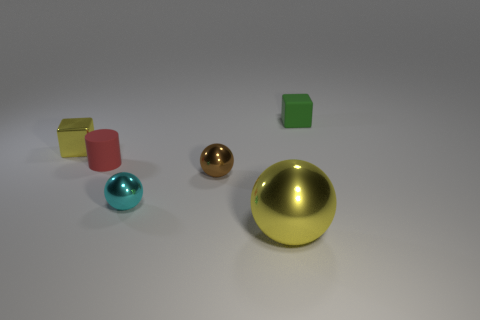Add 2 tiny red matte cylinders. How many objects exist? 8 Subtract all cubes. How many objects are left? 4 Subtract 1 yellow cubes. How many objects are left? 5 Subtract all tiny cyan shiny cubes. Subtract all small shiny blocks. How many objects are left? 5 Add 3 yellow shiny blocks. How many yellow shiny blocks are left? 4 Add 4 tiny yellow objects. How many tiny yellow objects exist? 5 